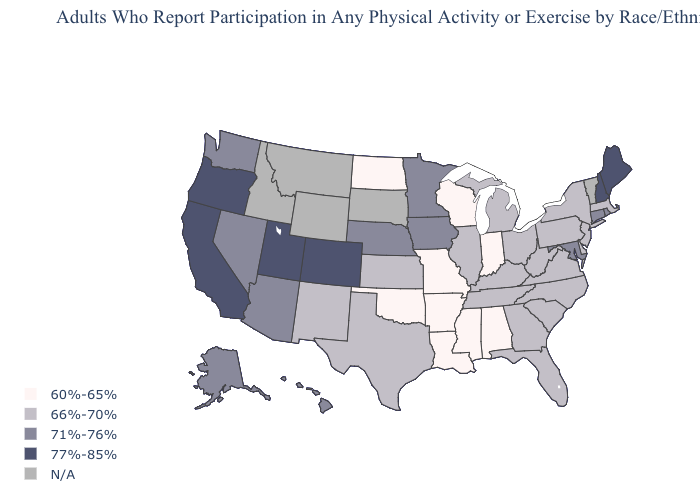Does North Dakota have the lowest value in the USA?
Give a very brief answer. Yes. Name the states that have a value in the range N/A?
Concise answer only. Idaho, Montana, South Dakota, Vermont, Wyoming. Which states have the highest value in the USA?
Give a very brief answer. California, Colorado, Maine, New Hampshire, Oregon, Utah. Does Louisiana have the lowest value in the USA?
Keep it brief. Yes. Among the states that border Louisiana , which have the lowest value?
Quick response, please. Arkansas, Mississippi. What is the highest value in the USA?
Keep it brief. 77%-85%. Which states have the lowest value in the USA?
Be succinct. Alabama, Arkansas, Indiana, Louisiana, Mississippi, Missouri, North Dakota, Oklahoma, Wisconsin. What is the value of Nevada?
Give a very brief answer. 71%-76%. What is the value of South Carolina?
Concise answer only. 66%-70%. Among the states that border Delaware , which have the lowest value?
Concise answer only. New Jersey, Pennsylvania. Among the states that border Oklahoma , does Colorado have the highest value?
Write a very short answer. Yes. Among the states that border Ohio , does West Virginia have the lowest value?
Concise answer only. No. Which states have the highest value in the USA?
Write a very short answer. California, Colorado, Maine, New Hampshire, Oregon, Utah. Name the states that have a value in the range 66%-70%?
Short answer required. Delaware, Florida, Georgia, Illinois, Kansas, Kentucky, Massachusetts, Michigan, New Jersey, New Mexico, New York, North Carolina, Ohio, Pennsylvania, South Carolina, Tennessee, Texas, Virginia, West Virginia. What is the highest value in states that border Washington?
Quick response, please. 77%-85%. 